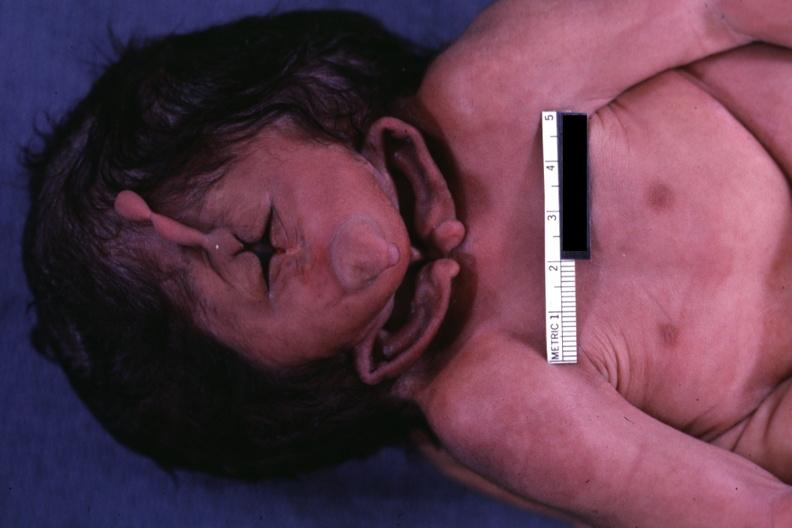what does this image show?
Answer the question using a single word or phrase. Close-up view of one side of head 